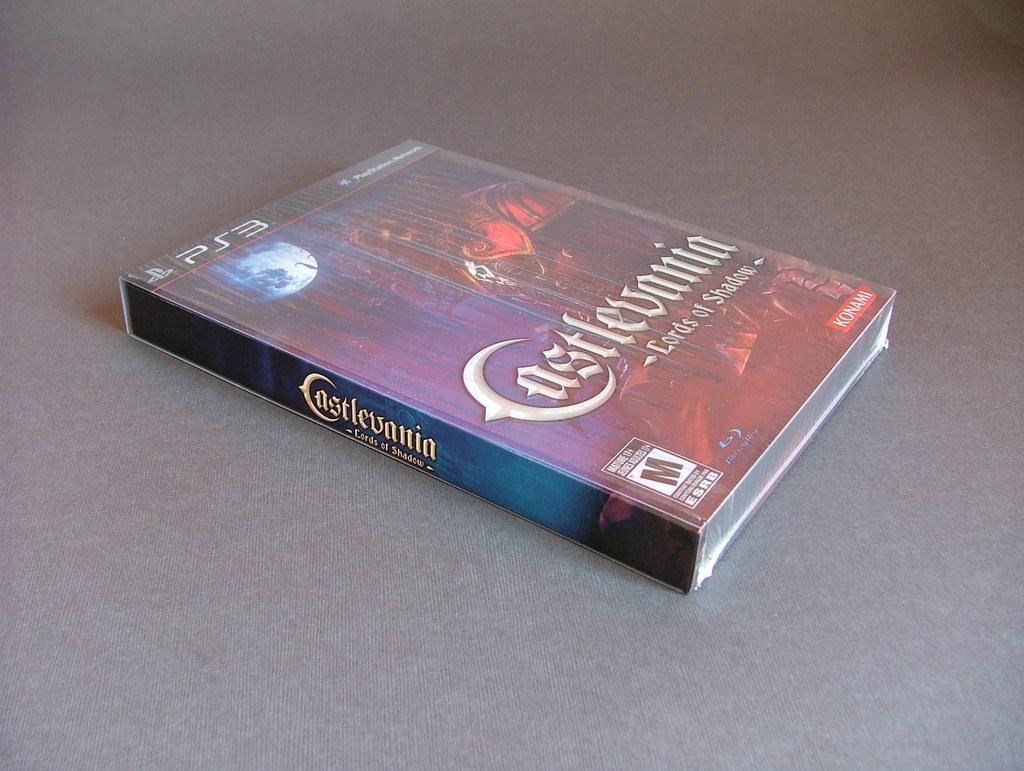<image>
Write a terse but informative summary of the picture. Castlevania for PS3 has a rating of M by the ESRB 